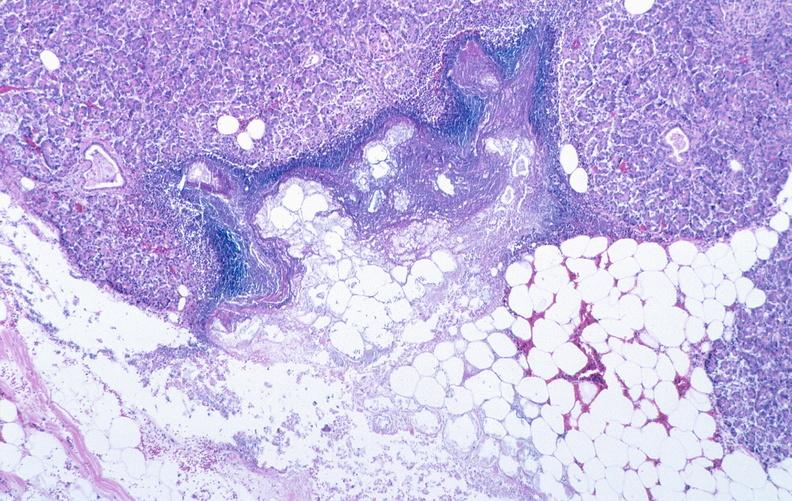does this image show pancreatic fat necrosis?
Answer the question using a single word or phrase. Yes 